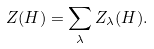Convert formula to latex. <formula><loc_0><loc_0><loc_500><loc_500>Z ( H ) = \sum _ { \lambda } { Z _ { \lambda } ( H ) } .</formula> 